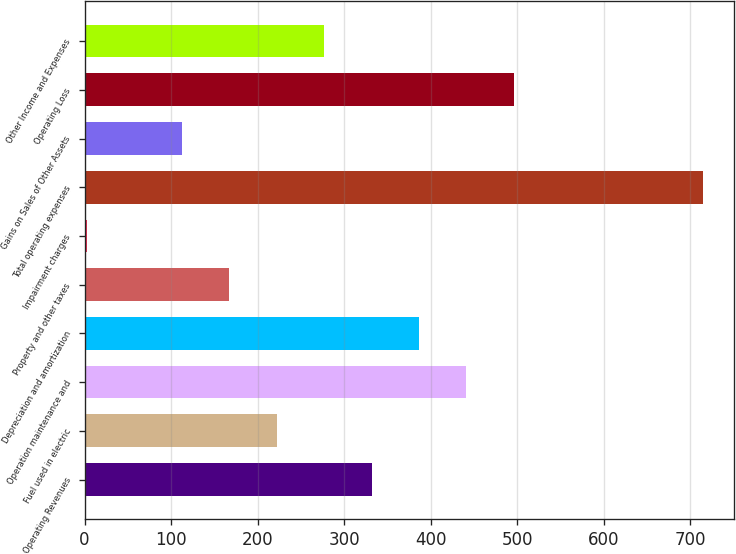<chart> <loc_0><loc_0><loc_500><loc_500><bar_chart><fcel>Operating Revenues<fcel>Fuel used in electric<fcel>Operation maintenance and<fcel>Depreciation and amortization<fcel>Property and other taxes<fcel>Impairment charges<fcel>Total operating expenses<fcel>Gains on Sales of Other Assets<fcel>Operating Loss<fcel>Other Income and Expenses<nl><fcel>331.8<fcel>222.2<fcel>441.4<fcel>386.6<fcel>167.4<fcel>3<fcel>715.4<fcel>112.6<fcel>496.2<fcel>277<nl></chart> 